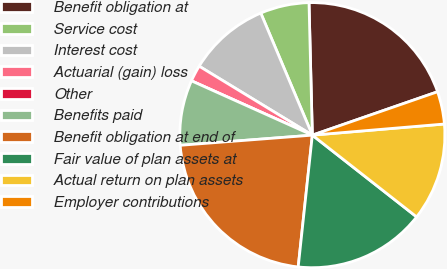<chart> <loc_0><loc_0><loc_500><loc_500><pie_chart><fcel>Benefit obligation at<fcel>Service cost<fcel>Interest cost<fcel>Actuarial (gain) loss<fcel>Other<fcel>Benefits paid<fcel>Benefit obligation at end of<fcel>Fair value of plan assets at<fcel>Actual return on plan assets<fcel>Employer contributions<nl><fcel>20.09%<fcel>5.96%<fcel>9.93%<fcel>1.99%<fcel>0.0%<fcel>7.94%<fcel>22.08%<fcel>16.12%<fcel>11.92%<fcel>3.97%<nl></chart> 